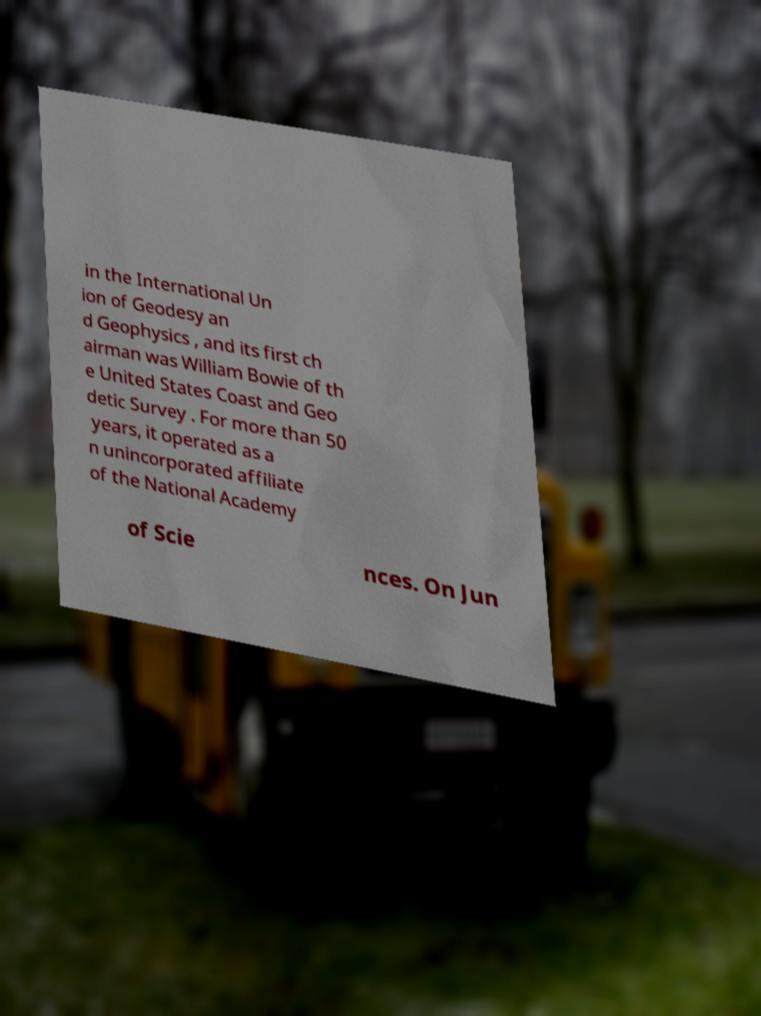Can you accurately transcribe the text from the provided image for me? in the International Un ion of Geodesy an d Geophysics , and its first ch airman was William Bowie of th e United States Coast and Geo detic Survey . For more than 50 years, it operated as a n unincorporated affiliate of the National Academy of Scie nces. On Jun 